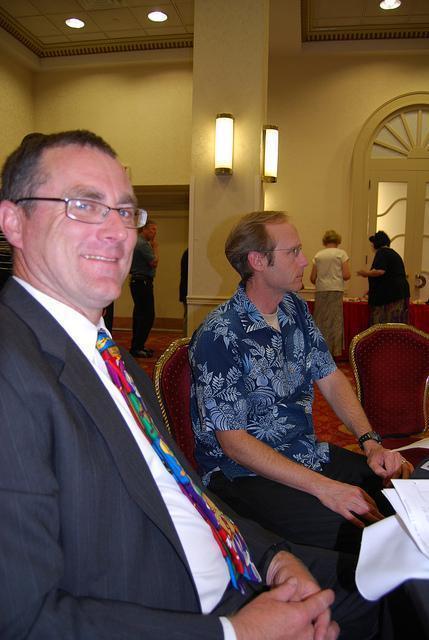How many people are there?
Give a very brief answer. 5. How many chairs are in the picture?
Give a very brief answer. 2. 